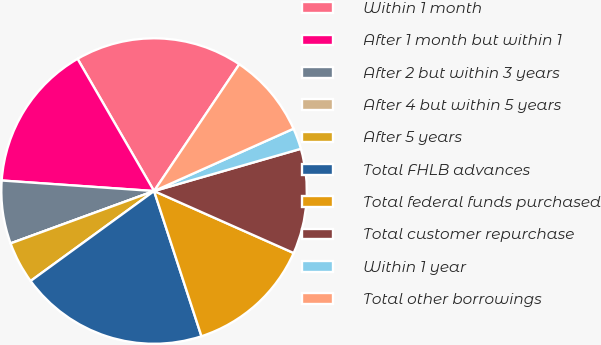Convert chart. <chart><loc_0><loc_0><loc_500><loc_500><pie_chart><fcel>Within 1 month<fcel>After 1 month but within 1<fcel>After 2 but within 3 years<fcel>After 4 but within 5 years<fcel>After 5 years<fcel>Total FHLB advances<fcel>Total federal funds purchased<fcel>Total customer repurchase<fcel>Within 1 year<fcel>Total other borrowings<nl><fcel>17.77%<fcel>15.55%<fcel>6.67%<fcel>0.0%<fcel>4.45%<fcel>20.0%<fcel>13.33%<fcel>11.11%<fcel>2.23%<fcel>8.89%<nl></chart> 